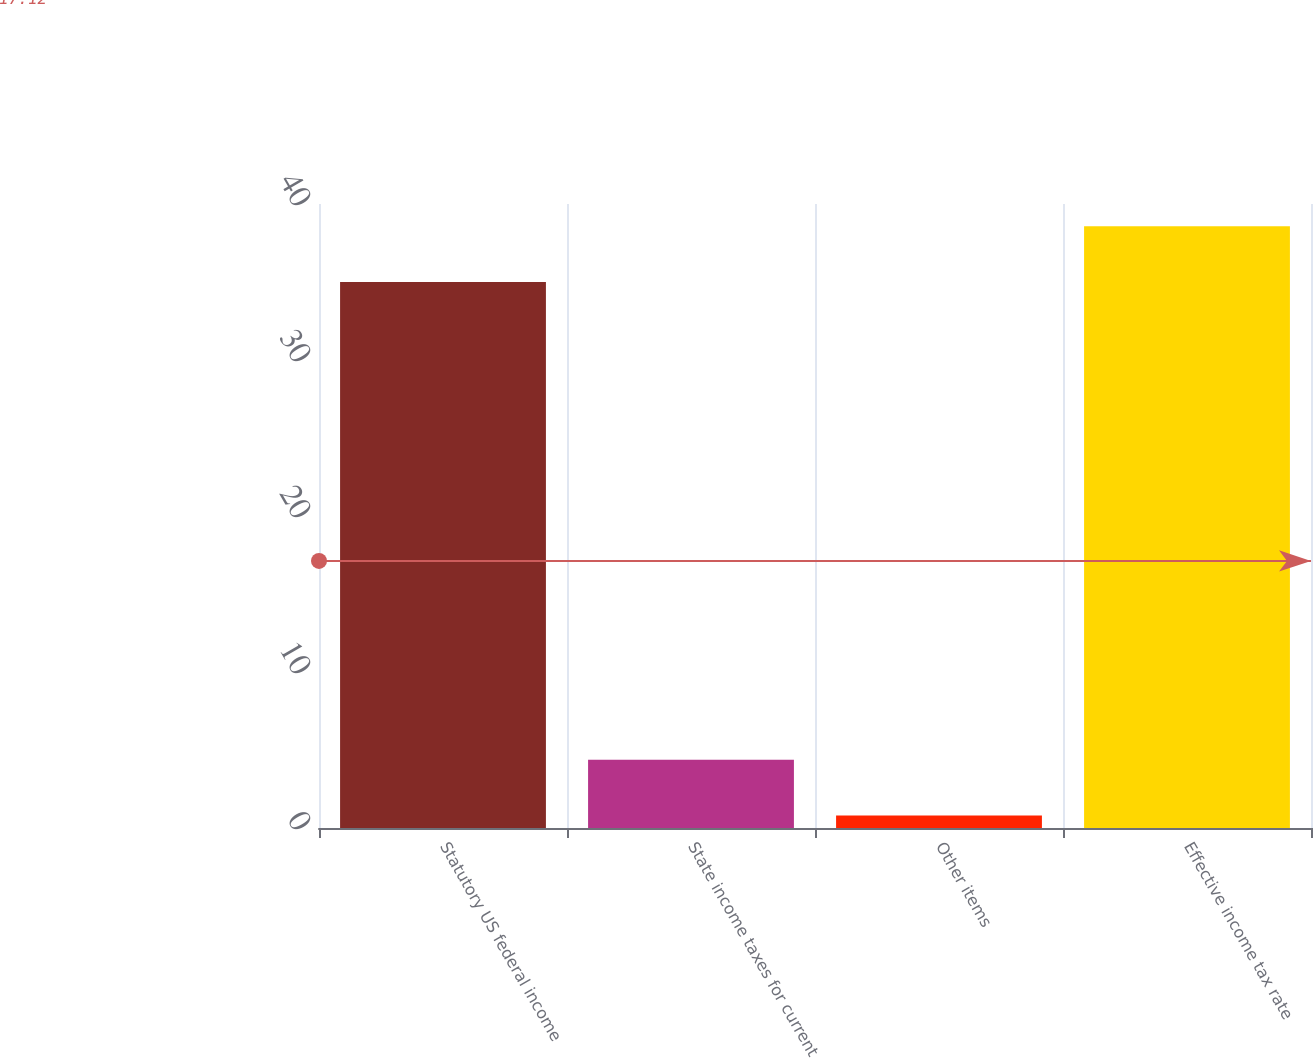Convert chart to OTSL. <chart><loc_0><loc_0><loc_500><loc_500><bar_chart><fcel>Statutory US federal income<fcel>State income taxes for current<fcel>Other items<fcel>Effective income tax rate<nl><fcel>35<fcel>4.38<fcel>0.8<fcel>38.58<nl></chart> 